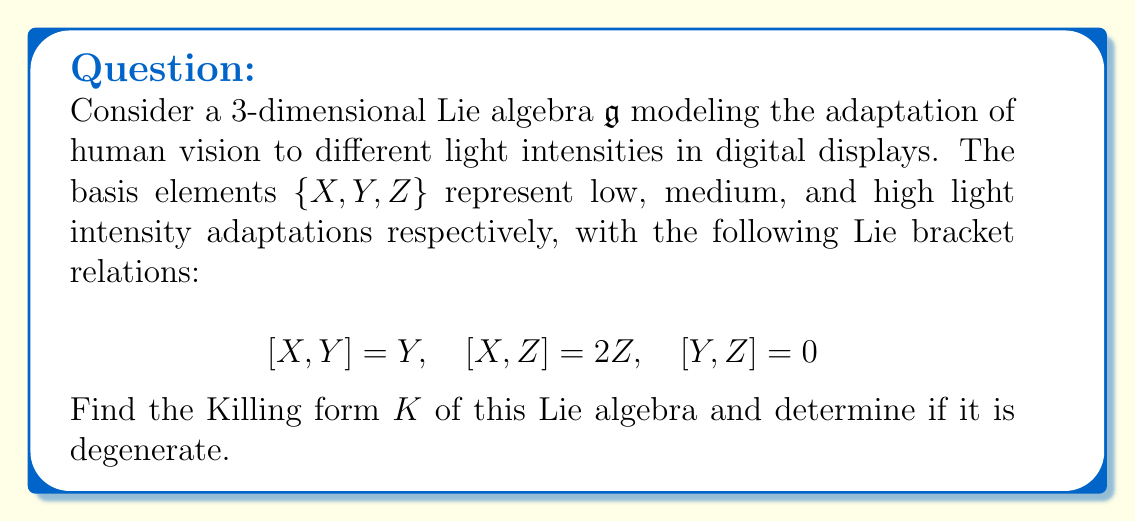Provide a solution to this math problem. To find the Killing form of the Lie algebra $\mathfrak{g}$, we need to follow these steps:

1) The Killing form $K$ is defined as $K(A,B) = \text{tr}(\text{ad}(A) \circ \text{ad}(B))$ for any $A,B \in \mathfrak{g}$.

2) First, we need to find the adjoint representations of the basis elements:

   For $X$: $\text{ad}(X) = \begin{pmatrix} 0 & 0 & 0 \\ 0 & 1 & 0 \\ 0 & 0 & 2 \end{pmatrix}$
   
   For $Y$: $\text{ad}(Y) = \begin{pmatrix} 0 & 0 & 0 \\ -1 & 0 & 0 \\ 0 & 0 & 0 \end{pmatrix}$
   
   For $Z$: $\text{ad}(Z) = \begin{pmatrix} 0 & 0 & 0 \\ 0 & 0 & 0 \\ -2 & 0 & 0 \end{pmatrix}$

3) Now, we can compute the Killing form for each pair of basis elements:

   $K(X,X) = \text{tr}(\text{ad}(X) \circ \text{ad}(X)) = \text{tr}\begin{pmatrix} 0 & 0 & 0 \\ 0 & 1 & 0 \\ 0 & 0 & 4 \end{pmatrix} = 5$
   
   $K(X,Y) = \text{tr}(\text{ad}(X) \circ \text{ad}(Y)) = \text{tr}\begin{pmatrix} 0 & 0 & 0 \\ -1 & 0 & 0 \\ 0 & 0 & 0 \end{pmatrix} = 0$
   
   $K(X,Z) = \text{tr}(\text{ad}(X) \circ \text{ad}(Z)) = \text{tr}\begin{pmatrix} 0 & 0 & 0 \\ 0 & 0 & 0 \\ -4 & 0 & 0 \end{pmatrix} = 0$
   
   $K(Y,Y) = \text{tr}(\text{ad}(Y) \circ \text{ad}(Y)) = \text{tr}\begin{pmatrix} 1 & 0 & 0 \\ 0 & 0 & 0 \\ 0 & 0 & 0 \end{pmatrix} = 1$
   
   $K(Y,Z) = \text{tr}(\text{ad}(Y) \circ \text{ad}(Z)) = \text{tr}\begin{pmatrix} 0 & 0 & 0 \\ 0 & 0 & 0 \\ 0 & 0 & 0 \end{pmatrix} = 0$
   
   $K(Z,Z) = \text{tr}(\text{ad}(Z) \circ \text{ad}(Z)) = \text{tr}\begin{pmatrix} 4 & 0 & 0 \\ 0 & 0 & 0 \\ 0 & 0 & 0 \end{pmatrix} = 4$

4) The Killing form matrix with respect to the basis $\{X, Y, Z\}$ is:

   $$K = \begin{pmatrix} 5 & 0 & 0 \\ 0 & 1 & 0 \\ 0 & 0 & 4 \end{pmatrix}$$

5) To determine if the Killing form is degenerate, we need to check if its determinant is zero:

   $\det(K) = 5 \cdot 1 \cdot 4 = 20 \neq 0$

   Since the determinant is non-zero, the Killing form is non-degenerate.
Answer: The Killing form of the given Lie algebra is:
$$K = \begin{pmatrix} 5 & 0 & 0 \\ 0 & 1 & 0 \\ 0 & 0 & 4 \end{pmatrix}$$
The Killing form is non-degenerate. 